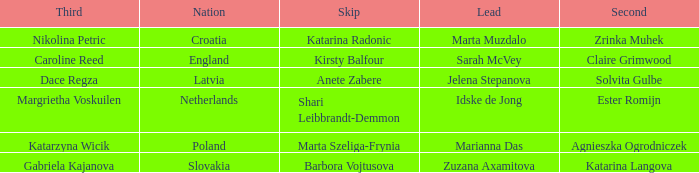I'm looking to parse the entire table for insights. Could you assist me with that? {'header': ['Third', 'Nation', 'Skip', 'Lead', 'Second'], 'rows': [['Nikolina Petric', 'Croatia', 'Katarina Radonic', 'Marta Muzdalo', 'Zrinka Muhek'], ['Caroline Reed', 'England', 'Kirsty Balfour', 'Sarah McVey', 'Claire Grimwood'], ['Dace Regza', 'Latvia', 'Anete Zabere', 'Jelena Stepanova', 'Solvita Gulbe'], ['Margrietha Voskuilen', 'Netherlands', 'Shari Leibbrandt-Demmon', 'Idske de Jong', 'Ester Romijn'], ['Katarzyna Wicik', 'Poland', 'Marta Szeliga-Frynia', 'Marianna Das', 'Agnieszka Ogrodniczek'], ['Gabriela Kajanova', 'Slovakia', 'Barbora Vojtusova', 'Zuzana Axamitova', 'Katarina Langova']]} Which skip has Zrinka Muhek as Second? Katarina Radonic. 